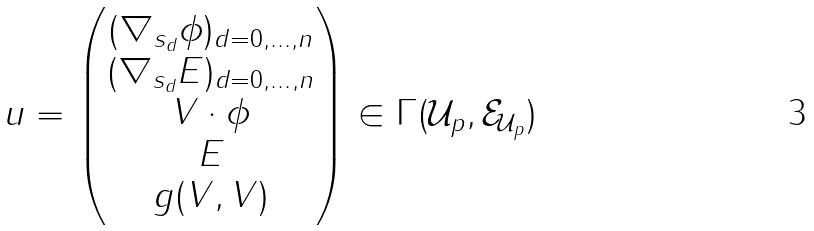<formula> <loc_0><loc_0><loc_500><loc_500>u = \begin{pmatrix} ( \nabla _ { s _ { d } } \phi ) _ { d = 0 , \dots , n } \\ ( \nabla _ { s _ { d } } E ) _ { d = 0 , \dots , n } \\ V \cdot \phi \\ E \\ g ( V , V ) \end{pmatrix} \in \Gamma ( \mathcal { U } _ { p } , { \mathcal { E } } _ { \mathcal { U } _ { p } } )</formula> 